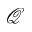<formula> <loc_0><loc_0><loc_500><loc_500>\mathcal { Q }</formula> 